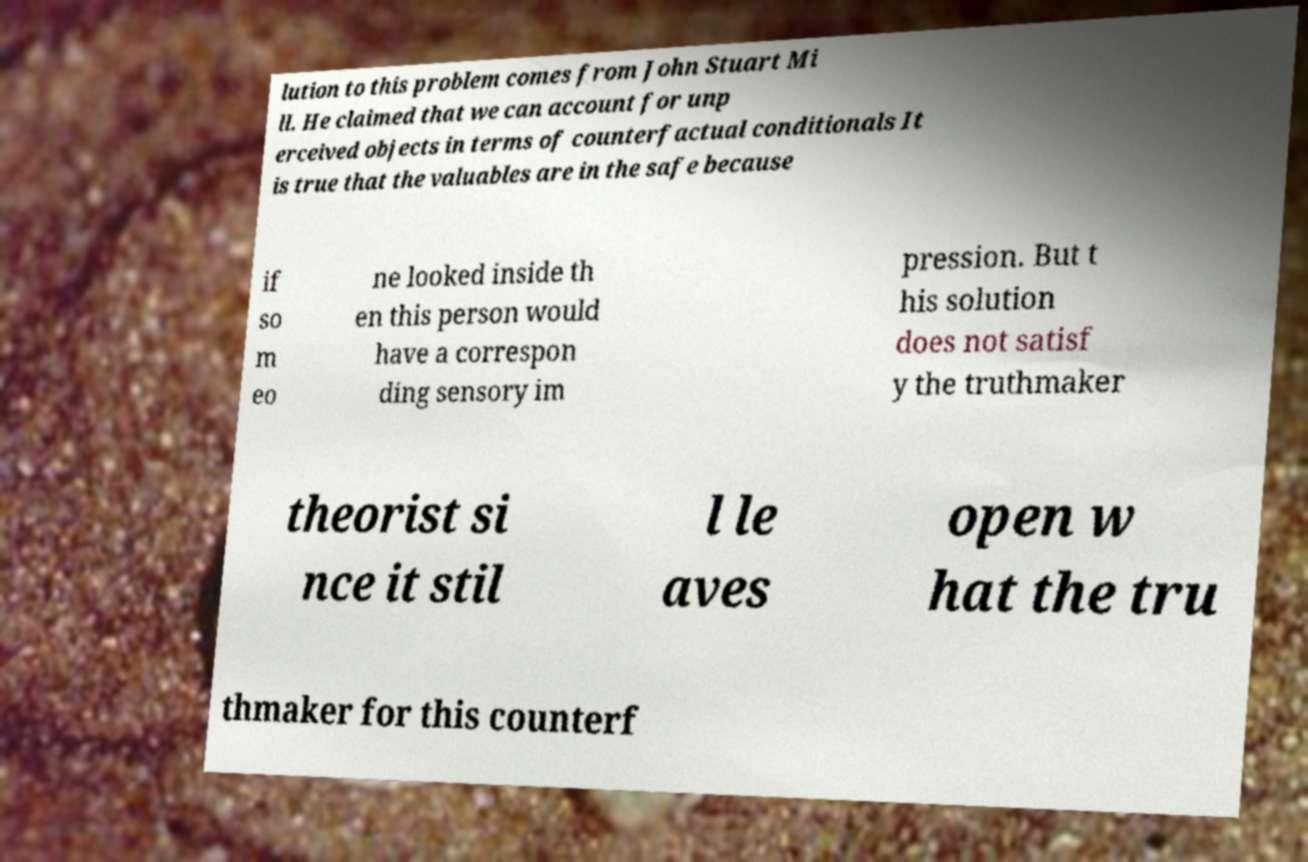Could you assist in decoding the text presented in this image and type it out clearly? lution to this problem comes from John Stuart Mi ll. He claimed that we can account for unp erceived objects in terms of counterfactual conditionals It is true that the valuables are in the safe because if so m eo ne looked inside th en this person would have a correspon ding sensory im pression. But t his solution does not satisf y the truthmaker theorist si nce it stil l le aves open w hat the tru thmaker for this counterf 